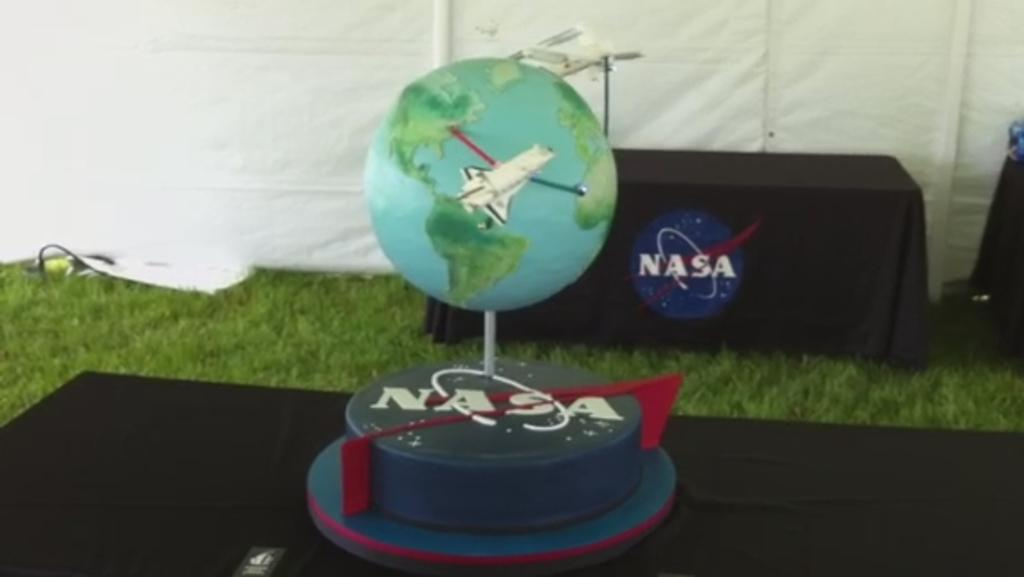What is the main subject in the foreground of the image? There is a cake in the foreground of the image. Where is the cake placed? The cake is on a table. What can be seen in the background of the image? There is a table in the background of the image. How is the table in the background decorated? The table in the background has a black cloth on it, and there is a white canopy above it. How does the cake transport itself to the table in the background? The cake does not transport itself; it is already on a table in the foreground. What type of ring is visible on the cake in the image? There is no ring visible on the cake in the image. 